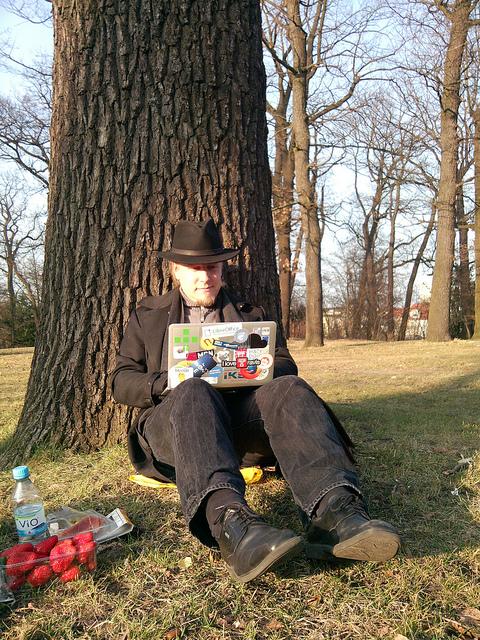What beverage does the man have nearby?
Quick response, please. Water. Is the man kissing a tree?
Concise answer only. No. What is the man holding on his lap?
Short answer required. Laptop. 